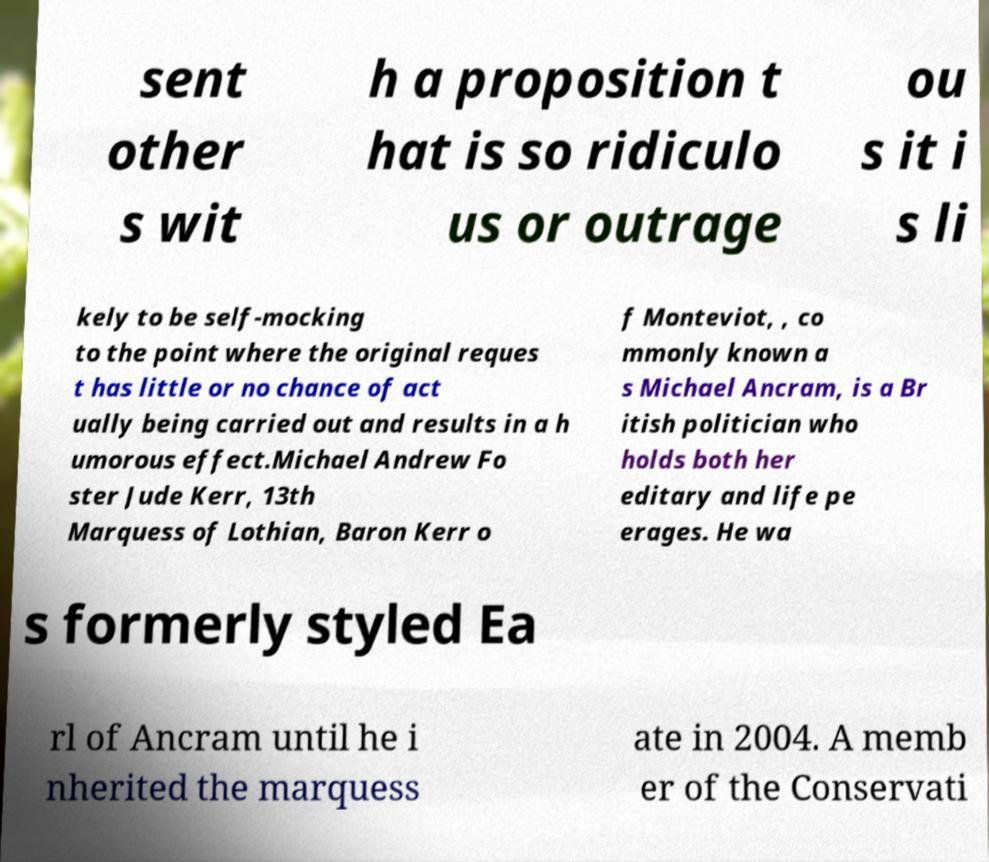Can you accurately transcribe the text from the provided image for me? sent other s wit h a proposition t hat is so ridiculo us or outrage ou s it i s li kely to be self-mocking to the point where the original reques t has little or no chance of act ually being carried out and results in a h umorous effect.Michael Andrew Fo ster Jude Kerr, 13th Marquess of Lothian, Baron Kerr o f Monteviot, , co mmonly known a s Michael Ancram, is a Br itish politician who holds both her editary and life pe erages. He wa s formerly styled Ea rl of Ancram until he i nherited the marquess ate in 2004. A memb er of the Conservati 